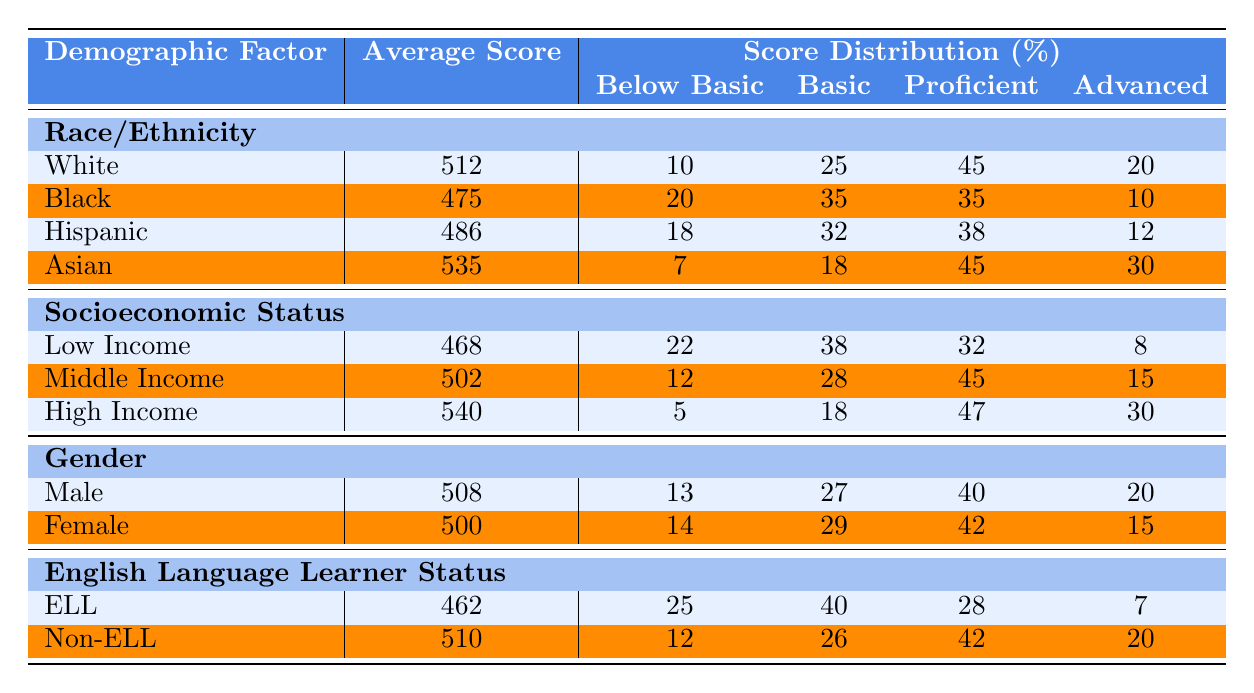What is the average score for the Asian demographic group? Referring to the table, the average score listed for the Asian group is directly given as 535.
Answer: 535 What percentage of Low Income students scored Below Basic? The table indicates that 22% of students from the Low Income group scored Below Basic.
Answer: 22% Which demographic group has the highest average score? By comparing the average scores among all groups, the Asian group has the highest average score of 535.
Answer: Asian How many percent of High Income students scored Advanced? Checking the score distribution for the High Income group, it shows that 30% of students scored Advanced.
Answer: 30% What is the difference in average score between Low Income and High Income students? The average score for Low Income students is 468, and for High Income students it is 540. The difference is 540 - 468 = 72.
Answer: 72 How many students scored Proficient in the Hispanic demographic group? For the Hispanic group, 38% scored Proficient. Since we do not have total student numbers, we cannot determine an exact count. Therefore, the percentage is the best information available.
Answer: 38% Did more females score Below Basic compared to males? From the table, it can be seen that 14% of females and 13% of males scored Below Basic. Therefore, more females did score Below Basic.
Answer: Yes What is the average score of Non-ELL students? The table indicates that Non-ELL students have an average score of 510.
Answer: 510 If you combine the Advanced percentages of Black and Hispanic groups, what do you get? The percentage of Advanced students in the Black group is 10%, and in the Hispanic group, it is 12%. Combining these gives 10 + 12 = 22%.
Answer: 22% Among all groups, which one has the highest percentage of students scoring Below Basic? The ELL group has the highest percentage of students scoring Below Basic at 25%.
Answer: ELL 